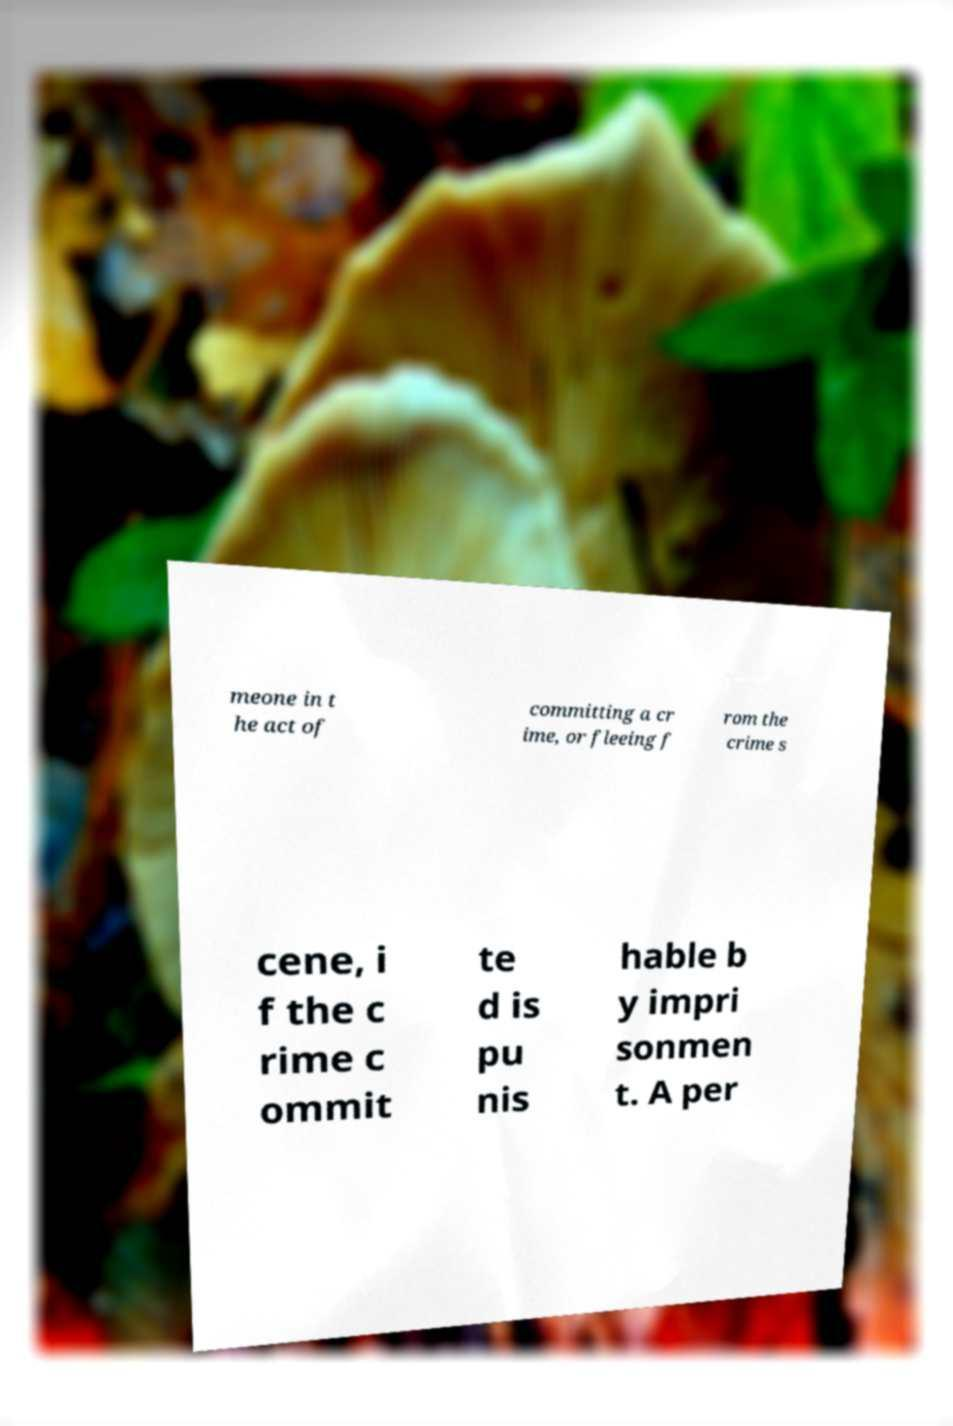Could you extract and type out the text from this image? meone in t he act of committing a cr ime, or fleeing f rom the crime s cene, i f the c rime c ommit te d is pu nis hable b y impri sonmen t. A per 